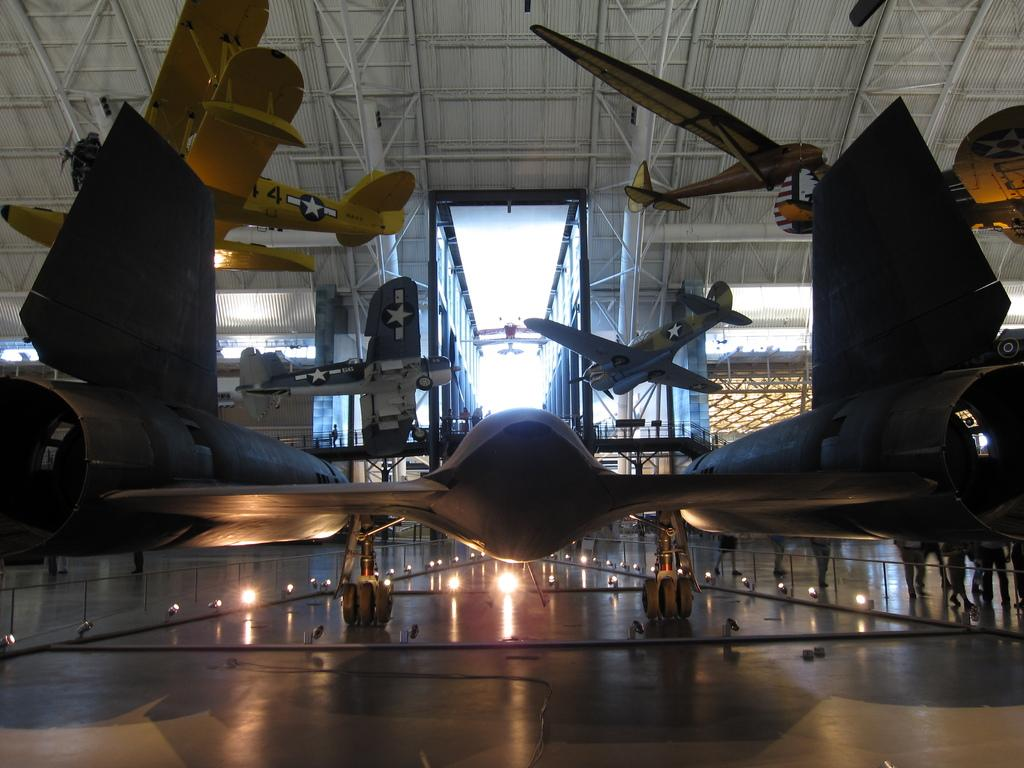What is the main subject of the image? The national air and space museum is in the image. What can be seen at the top side of the image? There is a roof at the top side of the image. What is visible at the bottom side of the image? There are lights at the bottom side of the image. Can you see a monkey playing with a car in the image? No, there is no monkey or car present in the image. The image features the national air and space museum, a roof, and lights. 